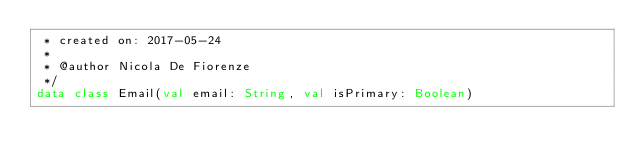<code> <loc_0><loc_0><loc_500><loc_500><_Kotlin_> * created on: 2017-05-24
 *
 * @author Nicola De Fiorenze
 */
data class Email(val email: String, val isPrimary: Boolean)</code> 